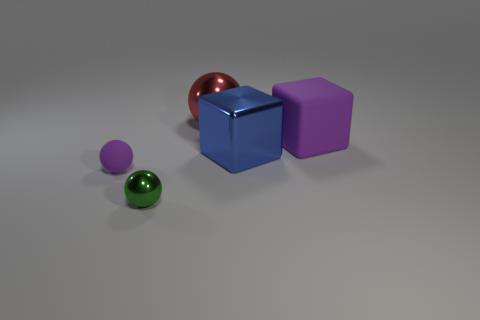The other tiny thing that is the same shape as the small purple object is what color? The small object sharing the same spherical shape as the purple sphere is a rich, emerald green color. 